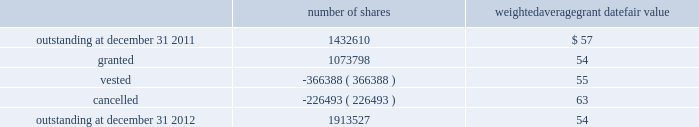The weighted average grant date fair value of options granted during 2012 , 2011 , and 2010 was $ 13 , $ 19 and $ 20 per share , respectively .
The total intrinsic value of options exercised during the years ended december 31 , 2012 , 2011 and 2010 , was $ 19.0 million , $ 4.2 million and $ 15.6 million , respectively .
In 2012 , the company granted 931340 shares of restricted class a common stock and 4048 shares of restricted stock units .
Restricted common stock and restricted stock units generally have a vesting period of 2 to 4 years .
The fair value related to these grants was $ 54.5 million , which is recognized as compensation expense on an accelerated basis over the vesting period .
Beginning with restricted stock grants in september 2010 , dividends are accrued on restricted class a common stock and restricted stock units and are paid once the restricted stock vests .
In 2012 , the company also granted 138410 performance shares .
The fair value related to these grants was $ 7.7 million , which is recognized as compensation expense on an accelerated and straight-lined basis over the vesting period .
The vesting of these shares is contingent on meeting stated performance or market conditions .
The table summarizes restricted stock , restricted stock units , and performance shares activity for 2012 : number of shares weighted average grant date fair value outstanding at december 31 , 2011 .
1432610 $ 57 .
Outstanding at december 31 , 2012 .
1913527 54 the total fair value of restricted stock , restricted stock units , and performance shares that vested during the years ended december 31 , 2012 , 2011 and 2010 , was $ 20.9 million , $ 11.6 million and $ 10.3 million , respectively .
Eligible employees may acquire shares of class a common stock using after-tax payroll deductions made during consecutive offering periods of approximately six months in duration .
Shares are purchased at the end of each offering period at a price of 90% ( 90 % ) of the closing price of the class a common stock as reported on the nasdaq global select market .
Compensation expense is recognized on the dates of purchase for the discount from the closing price .
In 2012 , 2011 and 2010 , a total of 27768 , 32085 and 21855 shares , respectively , of class a common stock were issued to participating employees .
These shares are subject to a six-month holding period .
Annual expense of $ 0.1 million , $ 0.2 million and $ 0.1 million for the purchase discount was recognized in 2012 , 2011 and 2010 , respectively .
Non-executive directors receive an annual award of class a common stock with a value equal to $ 75000 .
Non-executive directors may also elect to receive some or all of the cash portion of their annual stipend , up to $ 25000 , in shares of stock based on the closing price at the date of distribution .
As a result , 40260 , 40585 and 37350 shares of class a common stock were issued to non-executive directors during 2012 , 2011 and 2010 , respectively .
These shares are not subject to any vesting restrictions .
Expense of $ 2.2 million , $ 2.1 million and $ 2.4 million related to these stock-based payments was recognized for the years ended december 31 , 2012 , 2011 and 2010 , respectively .
19 .
Fair value measurements in general , the company uses quoted prices in active markets for identical assets to determine the fair value of marketable securities and equity investments .
Level 1 assets generally include u.s .
Treasury securities , equity securities listed in active markets , and investments in publicly traded mutual funds with quoted market prices .
If quoted prices are not available to determine fair value , the company uses other inputs that are directly observable .
Assets included in level 2 generally consist of asset- backed securities , municipal bonds , u.s .
Government agency securities and interest rate swap contracts .
Asset-backed securities , municipal bonds and u.s .
Government agency securities were measured at fair value based on matrix pricing using prices of similar securities with similar inputs such as maturity dates , interest rates and credit ratings .
The company determined the fair value of its interest rate swap contracts using standard valuation models with market-based observable inputs including forward and spot exchange rates and interest rate curves. .
What is the percentage change in the total value of outstanding balance from 2011 to 2012? 
Computations: (((1913527 * 54) - (1432610 * 57)) / (1432610 * 57))
Answer: 0.26539. 